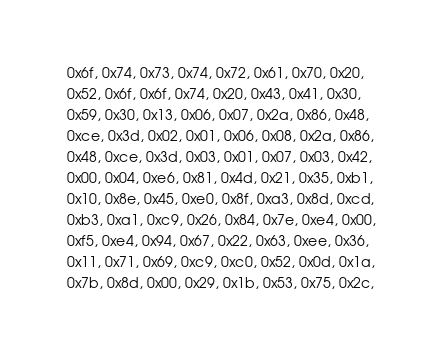Convert code to text. <code><loc_0><loc_0><loc_500><loc_500><_C_> 0x6f, 0x74, 0x73, 0x74, 0x72, 0x61, 0x70, 0x20,
 0x52, 0x6f, 0x6f, 0x74, 0x20, 0x43, 0x41, 0x30,
 0x59, 0x30, 0x13, 0x06, 0x07, 0x2a, 0x86, 0x48,
 0xce, 0x3d, 0x02, 0x01, 0x06, 0x08, 0x2a, 0x86,
 0x48, 0xce, 0x3d, 0x03, 0x01, 0x07, 0x03, 0x42,
 0x00, 0x04, 0xe6, 0x81, 0x4d, 0x21, 0x35, 0xb1,
 0x10, 0x8e, 0x45, 0xe0, 0x8f, 0xa3, 0x8d, 0xcd,
 0xb3, 0xa1, 0xc9, 0x26, 0x84, 0x7e, 0xe4, 0x00,
 0xf5, 0xe4, 0x94, 0x67, 0x22, 0x63, 0xee, 0x36,
 0x11, 0x71, 0x69, 0xc9, 0xc0, 0x52, 0x0d, 0x1a,
 0x7b, 0x8d, 0x00, 0x29, 0x1b, 0x53, 0x75, 0x2c,</code> 